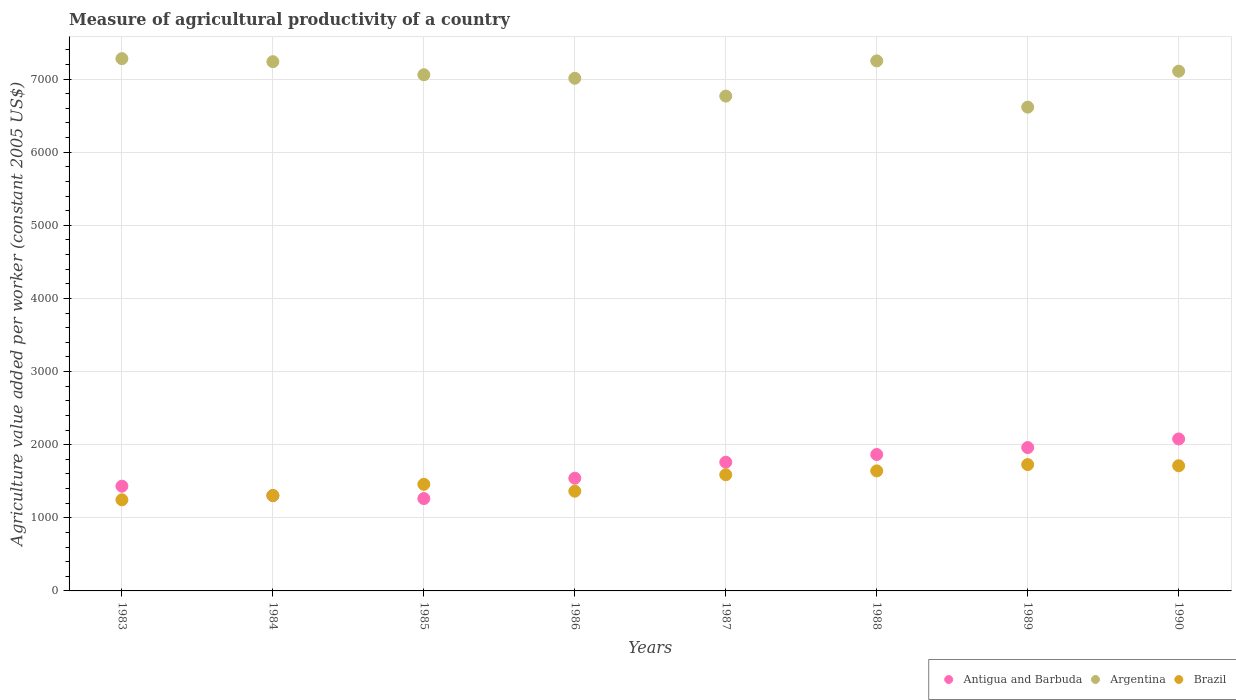What is the measure of agricultural productivity in Brazil in 1988?
Your answer should be very brief. 1641.28. Across all years, what is the maximum measure of agricultural productivity in Antigua and Barbuda?
Your answer should be compact. 2078.08. Across all years, what is the minimum measure of agricultural productivity in Brazil?
Provide a succinct answer. 1246. In which year was the measure of agricultural productivity in Brazil maximum?
Make the answer very short. 1989. What is the total measure of agricultural productivity in Argentina in the graph?
Your answer should be compact. 5.63e+04. What is the difference between the measure of agricultural productivity in Antigua and Barbuda in 1983 and that in 1984?
Offer a terse response. 130.05. What is the difference between the measure of agricultural productivity in Argentina in 1986 and the measure of agricultural productivity in Antigua and Barbuda in 1990?
Your answer should be compact. 4932.41. What is the average measure of agricultural productivity in Brazil per year?
Your answer should be compact. 1505.25. In the year 1989, what is the difference between the measure of agricultural productivity in Antigua and Barbuda and measure of agricultural productivity in Argentina?
Offer a terse response. -4655.16. What is the ratio of the measure of agricultural productivity in Argentina in 1987 to that in 1990?
Make the answer very short. 0.95. Is the measure of agricultural productivity in Antigua and Barbuda in 1985 less than that in 1987?
Your answer should be very brief. Yes. What is the difference between the highest and the second highest measure of agricultural productivity in Antigua and Barbuda?
Your response must be concise. 117.46. What is the difference between the highest and the lowest measure of agricultural productivity in Antigua and Barbuda?
Offer a terse response. 815.05. In how many years, is the measure of agricultural productivity in Argentina greater than the average measure of agricultural productivity in Argentina taken over all years?
Your answer should be very brief. 5. Does the measure of agricultural productivity in Antigua and Barbuda monotonically increase over the years?
Your answer should be compact. No. How many dotlines are there?
Your answer should be compact. 3. What is the difference between two consecutive major ticks on the Y-axis?
Keep it short and to the point. 1000. Are the values on the major ticks of Y-axis written in scientific E-notation?
Keep it short and to the point. No. Does the graph contain any zero values?
Keep it short and to the point. No. Where does the legend appear in the graph?
Your response must be concise. Bottom right. How many legend labels are there?
Your answer should be compact. 3. How are the legend labels stacked?
Keep it short and to the point. Horizontal. What is the title of the graph?
Make the answer very short. Measure of agricultural productivity of a country. What is the label or title of the Y-axis?
Your answer should be very brief. Agriculture value added per worker (constant 2005 US$). What is the Agriculture value added per worker (constant 2005 US$) of Antigua and Barbuda in 1983?
Offer a very short reply. 1432.54. What is the Agriculture value added per worker (constant 2005 US$) in Argentina in 1983?
Make the answer very short. 7278.97. What is the Agriculture value added per worker (constant 2005 US$) in Brazil in 1983?
Provide a short and direct response. 1246. What is the Agriculture value added per worker (constant 2005 US$) in Antigua and Barbuda in 1984?
Make the answer very short. 1302.49. What is the Agriculture value added per worker (constant 2005 US$) in Argentina in 1984?
Give a very brief answer. 7237.52. What is the Agriculture value added per worker (constant 2005 US$) of Brazil in 1984?
Your answer should be compact. 1304.93. What is the Agriculture value added per worker (constant 2005 US$) of Antigua and Barbuda in 1985?
Give a very brief answer. 1263.03. What is the Agriculture value added per worker (constant 2005 US$) of Argentina in 1985?
Provide a succinct answer. 7058.64. What is the Agriculture value added per worker (constant 2005 US$) of Brazil in 1985?
Your answer should be compact. 1457.79. What is the Agriculture value added per worker (constant 2005 US$) in Antigua and Barbuda in 1986?
Offer a terse response. 1541.44. What is the Agriculture value added per worker (constant 2005 US$) in Argentina in 1986?
Ensure brevity in your answer.  7010.49. What is the Agriculture value added per worker (constant 2005 US$) of Brazil in 1986?
Give a very brief answer. 1363.88. What is the Agriculture value added per worker (constant 2005 US$) in Antigua and Barbuda in 1987?
Keep it short and to the point. 1760.21. What is the Agriculture value added per worker (constant 2005 US$) in Argentina in 1987?
Ensure brevity in your answer.  6766.74. What is the Agriculture value added per worker (constant 2005 US$) in Brazil in 1987?
Your answer should be very brief. 1588.76. What is the Agriculture value added per worker (constant 2005 US$) of Antigua and Barbuda in 1988?
Your answer should be compact. 1865.43. What is the Agriculture value added per worker (constant 2005 US$) of Argentina in 1988?
Provide a short and direct response. 7248.35. What is the Agriculture value added per worker (constant 2005 US$) in Brazil in 1988?
Your response must be concise. 1641.28. What is the Agriculture value added per worker (constant 2005 US$) of Antigua and Barbuda in 1989?
Your answer should be compact. 1960.62. What is the Agriculture value added per worker (constant 2005 US$) in Argentina in 1989?
Ensure brevity in your answer.  6615.78. What is the Agriculture value added per worker (constant 2005 US$) of Brazil in 1989?
Offer a very short reply. 1727.74. What is the Agriculture value added per worker (constant 2005 US$) in Antigua and Barbuda in 1990?
Your answer should be very brief. 2078.08. What is the Agriculture value added per worker (constant 2005 US$) in Argentina in 1990?
Provide a succinct answer. 7107.59. What is the Agriculture value added per worker (constant 2005 US$) of Brazil in 1990?
Provide a succinct answer. 1711.61. Across all years, what is the maximum Agriculture value added per worker (constant 2005 US$) of Antigua and Barbuda?
Give a very brief answer. 2078.08. Across all years, what is the maximum Agriculture value added per worker (constant 2005 US$) in Argentina?
Your answer should be compact. 7278.97. Across all years, what is the maximum Agriculture value added per worker (constant 2005 US$) in Brazil?
Offer a very short reply. 1727.74. Across all years, what is the minimum Agriculture value added per worker (constant 2005 US$) of Antigua and Barbuda?
Offer a terse response. 1263.03. Across all years, what is the minimum Agriculture value added per worker (constant 2005 US$) in Argentina?
Give a very brief answer. 6615.78. Across all years, what is the minimum Agriculture value added per worker (constant 2005 US$) of Brazil?
Keep it short and to the point. 1246. What is the total Agriculture value added per worker (constant 2005 US$) in Antigua and Barbuda in the graph?
Ensure brevity in your answer.  1.32e+04. What is the total Agriculture value added per worker (constant 2005 US$) in Argentina in the graph?
Your response must be concise. 5.63e+04. What is the total Agriculture value added per worker (constant 2005 US$) in Brazil in the graph?
Give a very brief answer. 1.20e+04. What is the difference between the Agriculture value added per worker (constant 2005 US$) of Antigua and Barbuda in 1983 and that in 1984?
Ensure brevity in your answer.  130.05. What is the difference between the Agriculture value added per worker (constant 2005 US$) in Argentina in 1983 and that in 1984?
Your answer should be compact. 41.45. What is the difference between the Agriculture value added per worker (constant 2005 US$) in Brazil in 1983 and that in 1984?
Keep it short and to the point. -58.94. What is the difference between the Agriculture value added per worker (constant 2005 US$) of Antigua and Barbuda in 1983 and that in 1985?
Your answer should be very brief. 169.51. What is the difference between the Agriculture value added per worker (constant 2005 US$) in Argentina in 1983 and that in 1985?
Offer a very short reply. 220.33. What is the difference between the Agriculture value added per worker (constant 2005 US$) of Brazil in 1983 and that in 1985?
Keep it short and to the point. -211.8. What is the difference between the Agriculture value added per worker (constant 2005 US$) in Antigua and Barbuda in 1983 and that in 1986?
Give a very brief answer. -108.9. What is the difference between the Agriculture value added per worker (constant 2005 US$) in Argentina in 1983 and that in 1986?
Ensure brevity in your answer.  268.49. What is the difference between the Agriculture value added per worker (constant 2005 US$) of Brazil in 1983 and that in 1986?
Your answer should be compact. -117.89. What is the difference between the Agriculture value added per worker (constant 2005 US$) in Antigua and Barbuda in 1983 and that in 1987?
Provide a succinct answer. -327.67. What is the difference between the Agriculture value added per worker (constant 2005 US$) of Argentina in 1983 and that in 1987?
Keep it short and to the point. 512.23. What is the difference between the Agriculture value added per worker (constant 2005 US$) of Brazil in 1983 and that in 1987?
Your answer should be very brief. -342.76. What is the difference between the Agriculture value added per worker (constant 2005 US$) of Antigua and Barbuda in 1983 and that in 1988?
Ensure brevity in your answer.  -432.89. What is the difference between the Agriculture value added per worker (constant 2005 US$) of Argentina in 1983 and that in 1988?
Make the answer very short. 30.62. What is the difference between the Agriculture value added per worker (constant 2005 US$) of Brazil in 1983 and that in 1988?
Provide a succinct answer. -395.29. What is the difference between the Agriculture value added per worker (constant 2005 US$) in Antigua and Barbuda in 1983 and that in 1989?
Keep it short and to the point. -528.08. What is the difference between the Agriculture value added per worker (constant 2005 US$) of Argentina in 1983 and that in 1989?
Provide a succinct answer. 663.19. What is the difference between the Agriculture value added per worker (constant 2005 US$) in Brazil in 1983 and that in 1989?
Provide a succinct answer. -481.74. What is the difference between the Agriculture value added per worker (constant 2005 US$) of Antigua and Barbuda in 1983 and that in 1990?
Provide a short and direct response. -645.54. What is the difference between the Agriculture value added per worker (constant 2005 US$) of Argentina in 1983 and that in 1990?
Offer a terse response. 171.38. What is the difference between the Agriculture value added per worker (constant 2005 US$) in Brazil in 1983 and that in 1990?
Offer a terse response. -465.61. What is the difference between the Agriculture value added per worker (constant 2005 US$) in Antigua and Barbuda in 1984 and that in 1985?
Provide a succinct answer. 39.46. What is the difference between the Agriculture value added per worker (constant 2005 US$) in Argentina in 1984 and that in 1985?
Provide a succinct answer. 178.88. What is the difference between the Agriculture value added per worker (constant 2005 US$) in Brazil in 1984 and that in 1985?
Provide a short and direct response. -152.86. What is the difference between the Agriculture value added per worker (constant 2005 US$) of Antigua and Barbuda in 1984 and that in 1986?
Your answer should be very brief. -238.95. What is the difference between the Agriculture value added per worker (constant 2005 US$) of Argentina in 1984 and that in 1986?
Keep it short and to the point. 227.03. What is the difference between the Agriculture value added per worker (constant 2005 US$) in Brazil in 1984 and that in 1986?
Your answer should be very brief. -58.95. What is the difference between the Agriculture value added per worker (constant 2005 US$) of Antigua and Barbuda in 1984 and that in 1987?
Ensure brevity in your answer.  -457.73. What is the difference between the Agriculture value added per worker (constant 2005 US$) in Argentina in 1984 and that in 1987?
Your response must be concise. 470.78. What is the difference between the Agriculture value added per worker (constant 2005 US$) in Brazil in 1984 and that in 1987?
Your answer should be compact. -283.82. What is the difference between the Agriculture value added per worker (constant 2005 US$) of Antigua and Barbuda in 1984 and that in 1988?
Offer a very short reply. -562.94. What is the difference between the Agriculture value added per worker (constant 2005 US$) in Argentina in 1984 and that in 1988?
Your response must be concise. -10.83. What is the difference between the Agriculture value added per worker (constant 2005 US$) in Brazil in 1984 and that in 1988?
Make the answer very short. -336.35. What is the difference between the Agriculture value added per worker (constant 2005 US$) in Antigua and Barbuda in 1984 and that in 1989?
Your answer should be compact. -658.13. What is the difference between the Agriculture value added per worker (constant 2005 US$) in Argentina in 1984 and that in 1989?
Your answer should be very brief. 621.74. What is the difference between the Agriculture value added per worker (constant 2005 US$) of Brazil in 1984 and that in 1989?
Offer a terse response. -422.81. What is the difference between the Agriculture value added per worker (constant 2005 US$) of Antigua and Barbuda in 1984 and that in 1990?
Your response must be concise. -775.59. What is the difference between the Agriculture value added per worker (constant 2005 US$) in Argentina in 1984 and that in 1990?
Provide a short and direct response. 129.93. What is the difference between the Agriculture value added per worker (constant 2005 US$) in Brazil in 1984 and that in 1990?
Provide a succinct answer. -406.68. What is the difference between the Agriculture value added per worker (constant 2005 US$) in Antigua and Barbuda in 1985 and that in 1986?
Ensure brevity in your answer.  -278.41. What is the difference between the Agriculture value added per worker (constant 2005 US$) in Argentina in 1985 and that in 1986?
Provide a succinct answer. 48.16. What is the difference between the Agriculture value added per worker (constant 2005 US$) of Brazil in 1985 and that in 1986?
Provide a succinct answer. 93.91. What is the difference between the Agriculture value added per worker (constant 2005 US$) of Antigua and Barbuda in 1985 and that in 1987?
Ensure brevity in your answer.  -497.18. What is the difference between the Agriculture value added per worker (constant 2005 US$) of Argentina in 1985 and that in 1987?
Ensure brevity in your answer.  291.9. What is the difference between the Agriculture value added per worker (constant 2005 US$) of Brazil in 1985 and that in 1987?
Your answer should be compact. -130.96. What is the difference between the Agriculture value added per worker (constant 2005 US$) in Antigua and Barbuda in 1985 and that in 1988?
Your answer should be very brief. -602.4. What is the difference between the Agriculture value added per worker (constant 2005 US$) in Argentina in 1985 and that in 1988?
Keep it short and to the point. -189.71. What is the difference between the Agriculture value added per worker (constant 2005 US$) of Brazil in 1985 and that in 1988?
Provide a succinct answer. -183.49. What is the difference between the Agriculture value added per worker (constant 2005 US$) in Antigua and Barbuda in 1985 and that in 1989?
Ensure brevity in your answer.  -697.59. What is the difference between the Agriculture value added per worker (constant 2005 US$) in Argentina in 1985 and that in 1989?
Keep it short and to the point. 442.86. What is the difference between the Agriculture value added per worker (constant 2005 US$) in Brazil in 1985 and that in 1989?
Your answer should be very brief. -269.95. What is the difference between the Agriculture value added per worker (constant 2005 US$) of Antigua and Barbuda in 1985 and that in 1990?
Your answer should be compact. -815.05. What is the difference between the Agriculture value added per worker (constant 2005 US$) in Argentina in 1985 and that in 1990?
Provide a succinct answer. -48.95. What is the difference between the Agriculture value added per worker (constant 2005 US$) in Brazil in 1985 and that in 1990?
Your answer should be very brief. -253.81. What is the difference between the Agriculture value added per worker (constant 2005 US$) of Antigua and Barbuda in 1986 and that in 1987?
Make the answer very short. -218.77. What is the difference between the Agriculture value added per worker (constant 2005 US$) of Argentina in 1986 and that in 1987?
Ensure brevity in your answer.  243.75. What is the difference between the Agriculture value added per worker (constant 2005 US$) of Brazil in 1986 and that in 1987?
Your answer should be very brief. -224.87. What is the difference between the Agriculture value added per worker (constant 2005 US$) in Antigua and Barbuda in 1986 and that in 1988?
Ensure brevity in your answer.  -323.99. What is the difference between the Agriculture value added per worker (constant 2005 US$) of Argentina in 1986 and that in 1988?
Make the answer very short. -237.87. What is the difference between the Agriculture value added per worker (constant 2005 US$) of Brazil in 1986 and that in 1988?
Ensure brevity in your answer.  -277.4. What is the difference between the Agriculture value added per worker (constant 2005 US$) of Antigua and Barbuda in 1986 and that in 1989?
Offer a terse response. -419.18. What is the difference between the Agriculture value added per worker (constant 2005 US$) of Argentina in 1986 and that in 1989?
Provide a succinct answer. 394.7. What is the difference between the Agriculture value added per worker (constant 2005 US$) of Brazil in 1986 and that in 1989?
Offer a very short reply. -363.85. What is the difference between the Agriculture value added per worker (constant 2005 US$) of Antigua and Barbuda in 1986 and that in 1990?
Ensure brevity in your answer.  -536.64. What is the difference between the Agriculture value added per worker (constant 2005 US$) in Argentina in 1986 and that in 1990?
Offer a terse response. -97.11. What is the difference between the Agriculture value added per worker (constant 2005 US$) of Brazil in 1986 and that in 1990?
Keep it short and to the point. -347.72. What is the difference between the Agriculture value added per worker (constant 2005 US$) of Antigua and Barbuda in 1987 and that in 1988?
Offer a very short reply. -105.22. What is the difference between the Agriculture value added per worker (constant 2005 US$) of Argentina in 1987 and that in 1988?
Your answer should be compact. -481.61. What is the difference between the Agriculture value added per worker (constant 2005 US$) in Brazil in 1987 and that in 1988?
Your response must be concise. -52.53. What is the difference between the Agriculture value added per worker (constant 2005 US$) in Antigua and Barbuda in 1987 and that in 1989?
Make the answer very short. -200.41. What is the difference between the Agriculture value added per worker (constant 2005 US$) in Argentina in 1987 and that in 1989?
Offer a very short reply. 150.95. What is the difference between the Agriculture value added per worker (constant 2005 US$) in Brazil in 1987 and that in 1989?
Provide a succinct answer. -138.98. What is the difference between the Agriculture value added per worker (constant 2005 US$) in Antigua and Barbuda in 1987 and that in 1990?
Keep it short and to the point. -317.86. What is the difference between the Agriculture value added per worker (constant 2005 US$) of Argentina in 1987 and that in 1990?
Your answer should be very brief. -340.85. What is the difference between the Agriculture value added per worker (constant 2005 US$) in Brazil in 1987 and that in 1990?
Provide a succinct answer. -122.85. What is the difference between the Agriculture value added per worker (constant 2005 US$) in Antigua and Barbuda in 1988 and that in 1989?
Ensure brevity in your answer.  -95.19. What is the difference between the Agriculture value added per worker (constant 2005 US$) of Argentina in 1988 and that in 1989?
Offer a very short reply. 632.57. What is the difference between the Agriculture value added per worker (constant 2005 US$) of Brazil in 1988 and that in 1989?
Ensure brevity in your answer.  -86.46. What is the difference between the Agriculture value added per worker (constant 2005 US$) in Antigua and Barbuda in 1988 and that in 1990?
Ensure brevity in your answer.  -212.65. What is the difference between the Agriculture value added per worker (constant 2005 US$) in Argentina in 1988 and that in 1990?
Provide a short and direct response. 140.76. What is the difference between the Agriculture value added per worker (constant 2005 US$) of Brazil in 1988 and that in 1990?
Give a very brief answer. -70.33. What is the difference between the Agriculture value added per worker (constant 2005 US$) of Antigua and Barbuda in 1989 and that in 1990?
Provide a succinct answer. -117.46. What is the difference between the Agriculture value added per worker (constant 2005 US$) of Argentina in 1989 and that in 1990?
Give a very brief answer. -491.81. What is the difference between the Agriculture value added per worker (constant 2005 US$) of Brazil in 1989 and that in 1990?
Offer a terse response. 16.13. What is the difference between the Agriculture value added per worker (constant 2005 US$) in Antigua and Barbuda in 1983 and the Agriculture value added per worker (constant 2005 US$) in Argentina in 1984?
Make the answer very short. -5804.98. What is the difference between the Agriculture value added per worker (constant 2005 US$) in Antigua and Barbuda in 1983 and the Agriculture value added per worker (constant 2005 US$) in Brazil in 1984?
Your answer should be compact. 127.61. What is the difference between the Agriculture value added per worker (constant 2005 US$) in Argentina in 1983 and the Agriculture value added per worker (constant 2005 US$) in Brazil in 1984?
Your response must be concise. 5974.04. What is the difference between the Agriculture value added per worker (constant 2005 US$) of Antigua and Barbuda in 1983 and the Agriculture value added per worker (constant 2005 US$) of Argentina in 1985?
Your answer should be very brief. -5626.1. What is the difference between the Agriculture value added per worker (constant 2005 US$) in Antigua and Barbuda in 1983 and the Agriculture value added per worker (constant 2005 US$) in Brazil in 1985?
Make the answer very short. -25.26. What is the difference between the Agriculture value added per worker (constant 2005 US$) in Argentina in 1983 and the Agriculture value added per worker (constant 2005 US$) in Brazil in 1985?
Offer a very short reply. 5821.18. What is the difference between the Agriculture value added per worker (constant 2005 US$) in Antigua and Barbuda in 1983 and the Agriculture value added per worker (constant 2005 US$) in Argentina in 1986?
Ensure brevity in your answer.  -5577.95. What is the difference between the Agriculture value added per worker (constant 2005 US$) in Antigua and Barbuda in 1983 and the Agriculture value added per worker (constant 2005 US$) in Brazil in 1986?
Give a very brief answer. 68.65. What is the difference between the Agriculture value added per worker (constant 2005 US$) in Argentina in 1983 and the Agriculture value added per worker (constant 2005 US$) in Brazil in 1986?
Provide a short and direct response. 5915.09. What is the difference between the Agriculture value added per worker (constant 2005 US$) in Antigua and Barbuda in 1983 and the Agriculture value added per worker (constant 2005 US$) in Argentina in 1987?
Give a very brief answer. -5334.2. What is the difference between the Agriculture value added per worker (constant 2005 US$) in Antigua and Barbuda in 1983 and the Agriculture value added per worker (constant 2005 US$) in Brazil in 1987?
Keep it short and to the point. -156.22. What is the difference between the Agriculture value added per worker (constant 2005 US$) in Argentina in 1983 and the Agriculture value added per worker (constant 2005 US$) in Brazil in 1987?
Ensure brevity in your answer.  5690.22. What is the difference between the Agriculture value added per worker (constant 2005 US$) in Antigua and Barbuda in 1983 and the Agriculture value added per worker (constant 2005 US$) in Argentina in 1988?
Make the answer very short. -5815.81. What is the difference between the Agriculture value added per worker (constant 2005 US$) of Antigua and Barbuda in 1983 and the Agriculture value added per worker (constant 2005 US$) of Brazil in 1988?
Offer a terse response. -208.74. What is the difference between the Agriculture value added per worker (constant 2005 US$) of Argentina in 1983 and the Agriculture value added per worker (constant 2005 US$) of Brazil in 1988?
Ensure brevity in your answer.  5637.69. What is the difference between the Agriculture value added per worker (constant 2005 US$) in Antigua and Barbuda in 1983 and the Agriculture value added per worker (constant 2005 US$) in Argentina in 1989?
Ensure brevity in your answer.  -5183.25. What is the difference between the Agriculture value added per worker (constant 2005 US$) of Antigua and Barbuda in 1983 and the Agriculture value added per worker (constant 2005 US$) of Brazil in 1989?
Provide a short and direct response. -295.2. What is the difference between the Agriculture value added per worker (constant 2005 US$) in Argentina in 1983 and the Agriculture value added per worker (constant 2005 US$) in Brazil in 1989?
Ensure brevity in your answer.  5551.23. What is the difference between the Agriculture value added per worker (constant 2005 US$) of Antigua and Barbuda in 1983 and the Agriculture value added per worker (constant 2005 US$) of Argentina in 1990?
Your response must be concise. -5675.05. What is the difference between the Agriculture value added per worker (constant 2005 US$) in Antigua and Barbuda in 1983 and the Agriculture value added per worker (constant 2005 US$) in Brazil in 1990?
Give a very brief answer. -279.07. What is the difference between the Agriculture value added per worker (constant 2005 US$) in Argentina in 1983 and the Agriculture value added per worker (constant 2005 US$) in Brazil in 1990?
Make the answer very short. 5567.37. What is the difference between the Agriculture value added per worker (constant 2005 US$) of Antigua and Barbuda in 1984 and the Agriculture value added per worker (constant 2005 US$) of Argentina in 1985?
Offer a very short reply. -5756.16. What is the difference between the Agriculture value added per worker (constant 2005 US$) of Antigua and Barbuda in 1984 and the Agriculture value added per worker (constant 2005 US$) of Brazil in 1985?
Ensure brevity in your answer.  -155.31. What is the difference between the Agriculture value added per worker (constant 2005 US$) in Argentina in 1984 and the Agriculture value added per worker (constant 2005 US$) in Brazil in 1985?
Give a very brief answer. 5779.73. What is the difference between the Agriculture value added per worker (constant 2005 US$) in Antigua and Barbuda in 1984 and the Agriculture value added per worker (constant 2005 US$) in Argentina in 1986?
Offer a terse response. -5708. What is the difference between the Agriculture value added per worker (constant 2005 US$) in Antigua and Barbuda in 1984 and the Agriculture value added per worker (constant 2005 US$) in Brazil in 1986?
Give a very brief answer. -61.4. What is the difference between the Agriculture value added per worker (constant 2005 US$) of Argentina in 1984 and the Agriculture value added per worker (constant 2005 US$) of Brazil in 1986?
Provide a short and direct response. 5873.64. What is the difference between the Agriculture value added per worker (constant 2005 US$) in Antigua and Barbuda in 1984 and the Agriculture value added per worker (constant 2005 US$) in Argentina in 1987?
Make the answer very short. -5464.25. What is the difference between the Agriculture value added per worker (constant 2005 US$) in Antigua and Barbuda in 1984 and the Agriculture value added per worker (constant 2005 US$) in Brazil in 1987?
Your answer should be very brief. -286.27. What is the difference between the Agriculture value added per worker (constant 2005 US$) in Argentina in 1984 and the Agriculture value added per worker (constant 2005 US$) in Brazil in 1987?
Your answer should be very brief. 5648.76. What is the difference between the Agriculture value added per worker (constant 2005 US$) in Antigua and Barbuda in 1984 and the Agriculture value added per worker (constant 2005 US$) in Argentina in 1988?
Offer a terse response. -5945.87. What is the difference between the Agriculture value added per worker (constant 2005 US$) in Antigua and Barbuda in 1984 and the Agriculture value added per worker (constant 2005 US$) in Brazil in 1988?
Ensure brevity in your answer.  -338.8. What is the difference between the Agriculture value added per worker (constant 2005 US$) in Argentina in 1984 and the Agriculture value added per worker (constant 2005 US$) in Brazil in 1988?
Provide a short and direct response. 5596.24. What is the difference between the Agriculture value added per worker (constant 2005 US$) of Antigua and Barbuda in 1984 and the Agriculture value added per worker (constant 2005 US$) of Argentina in 1989?
Provide a succinct answer. -5313.3. What is the difference between the Agriculture value added per worker (constant 2005 US$) in Antigua and Barbuda in 1984 and the Agriculture value added per worker (constant 2005 US$) in Brazil in 1989?
Your answer should be compact. -425.25. What is the difference between the Agriculture value added per worker (constant 2005 US$) in Argentina in 1984 and the Agriculture value added per worker (constant 2005 US$) in Brazil in 1989?
Your answer should be very brief. 5509.78. What is the difference between the Agriculture value added per worker (constant 2005 US$) of Antigua and Barbuda in 1984 and the Agriculture value added per worker (constant 2005 US$) of Argentina in 1990?
Offer a terse response. -5805.11. What is the difference between the Agriculture value added per worker (constant 2005 US$) in Antigua and Barbuda in 1984 and the Agriculture value added per worker (constant 2005 US$) in Brazil in 1990?
Offer a terse response. -409.12. What is the difference between the Agriculture value added per worker (constant 2005 US$) of Argentina in 1984 and the Agriculture value added per worker (constant 2005 US$) of Brazil in 1990?
Provide a succinct answer. 5525.91. What is the difference between the Agriculture value added per worker (constant 2005 US$) of Antigua and Barbuda in 1985 and the Agriculture value added per worker (constant 2005 US$) of Argentina in 1986?
Provide a short and direct response. -5747.45. What is the difference between the Agriculture value added per worker (constant 2005 US$) in Antigua and Barbuda in 1985 and the Agriculture value added per worker (constant 2005 US$) in Brazil in 1986?
Your response must be concise. -100.85. What is the difference between the Agriculture value added per worker (constant 2005 US$) in Argentina in 1985 and the Agriculture value added per worker (constant 2005 US$) in Brazil in 1986?
Your answer should be compact. 5694.76. What is the difference between the Agriculture value added per worker (constant 2005 US$) in Antigua and Barbuda in 1985 and the Agriculture value added per worker (constant 2005 US$) in Argentina in 1987?
Offer a terse response. -5503.71. What is the difference between the Agriculture value added per worker (constant 2005 US$) of Antigua and Barbuda in 1985 and the Agriculture value added per worker (constant 2005 US$) of Brazil in 1987?
Your answer should be very brief. -325.73. What is the difference between the Agriculture value added per worker (constant 2005 US$) in Argentina in 1985 and the Agriculture value added per worker (constant 2005 US$) in Brazil in 1987?
Offer a very short reply. 5469.89. What is the difference between the Agriculture value added per worker (constant 2005 US$) in Antigua and Barbuda in 1985 and the Agriculture value added per worker (constant 2005 US$) in Argentina in 1988?
Ensure brevity in your answer.  -5985.32. What is the difference between the Agriculture value added per worker (constant 2005 US$) of Antigua and Barbuda in 1985 and the Agriculture value added per worker (constant 2005 US$) of Brazil in 1988?
Your answer should be very brief. -378.25. What is the difference between the Agriculture value added per worker (constant 2005 US$) of Argentina in 1985 and the Agriculture value added per worker (constant 2005 US$) of Brazil in 1988?
Your answer should be compact. 5417.36. What is the difference between the Agriculture value added per worker (constant 2005 US$) in Antigua and Barbuda in 1985 and the Agriculture value added per worker (constant 2005 US$) in Argentina in 1989?
Offer a very short reply. -5352.75. What is the difference between the Agriculture value added per worker (constant 2005 US$) of Antigua and Barbuda in 1985 and the Agriculture value added per worker (constant 2005 US$) of Brazil in 1989?
Offer a terse response. -464.71. What is the difference between the Agriculture value added per worker (constant 2005 US$) in Argentina in 1985 and the Agriculture value added per worker (constant 2005 US$) in Brazil in 1989?
Provide a short and direct response. 5330.9. What is the difference between the Agriculture value added per worker (constant 2005 US$) of Antigua and Barbuda in 1985 and the Agriculture value added per worker (constant 2005 US$) of Argentina in 1990?
Ensure brevity in your answer.  -5844.56. What is the difference between the Agriculture value added per worker (constant 2005 US$) of Antigua and Barbuda in 1985 and the Agriculture value added per worker (constant 2005 US$) of Brazil in 1990?
Give a very brief answer. -448.58. What is the difference between the Agriculture value added per worker (constant 2005 US$) in Argentina in 1985 and the Agriculture value added per worker (constant 2005 US$) in Brazil in 1990?
Ensure brevity in your answer.  5347.04. What is the difference between the Agriculture value added per worker (constant 2005 US$) of Antigua and Barbuda in 1986 and the Agriculture value added per worker (constant 2005 US$) of Argentina in 1987?
Offer a very short reply. -5225.3. What is the difference between the Agriculture value added per worker (constant 2005 US$) of Antigua and Barbuda in 1986 and the Agriculture value added per worker (constant 2005 US$) of Brazil in 1987?
Provide a short and direct response. -47.32. What is the difference between the Agriculture value added per worker (constant 2005 US$) of Argentina in 1986 and the Agriculture value added per worker (constant 2005 US$) of Brazil in 1987?
Offer a very short reply. 5421.73. What is the difference between the Agriculture value added per worker (constant 2005 US$) of Antigua and Barbuda in 1986 and the Agriculture value added per worker (constant 2005 US$) of Argentina in 1988?
Ensure brevity in your answer.  -5706.91. What is the difference between the Agriculture value added per worker (constant 2005 US$) in Antigua and Barbuda in 1986 and the Agriculture value added per worker (constant 2005 US$) in Brazil in 1988?
Your answer should be compact. -99.84. What is the difference between the Agriculture value added per worker (constant 2005 US$) in Argentina in 1986 and the Agriculture value added per worker (constant 2005 US$) in Brazil in 1988?
Your answer should be compact. 5369.2. What is the difference between the Agriculture value added per worker (constant 2005 US$) in Antigua and Barbuda in 1986 and the Agriculture value added per worker (constant 2005 US$) in Argentina in 1989?
Your answer should be very brief. -5074.35. What is the difference between the Agriculture value added per worker (constant 2005 US$) of Antigua and Barbuda in 1986 and the Agriculture value added per worker (constant 2005 US$) of Brazil in 1989?
Offer a very short reply. -186.3. What is the difference between the Agriculture value added per worker (constant 2005 US$) in Argentina in 1986 and the Agriculture value added per worker (constant 2005 US$) in Brazil in 1989?
Keep it short and to the point. 5282.75. What is the difference between the Agriculture value added per worker (constant 2005 US$) in Antigua and Barbuda in 1986 and the Agriculture value added per worker (constant 2005 US$) in Argentina in 1990?
Offer a very short reply. -5566.15. What is the difference between the Agriculture value added per worker (constant 2005 US$) of Antigua and Barbuda in 1986 and the Agriculture value added per worker (constant 2005 US$) of Brazil in 1990?
Make the answer very short. -170.17. What is the difference between the Agriculture value added per worker (constant 2005 US$) in Argentina in 1986 and the Agriculture value added per worker (constant 2005 US$) in Brazil in 1990?
Keep it short and to the point. 5298.88. What is the difference between the Agriculture value added per worker (constant 2005 US$) in Antigua and Barbuda in 1987 and the Agriculture value added per worker (constant 2005 US$) in Argentina in 1988?
Provide a succinct answer. -5488.14. What is the difference between the Agriculture value added per worker (constant 2005 US$) in Antigua and Barbuda in 1987 and the Agriculture value added per worker (constant 2005 US$) in Brazil in 1988?
Provide a succinct answer. 118.93. What is the difference between the Agriculture value added per worker (constant 2005 US$) in Argentina in 1987 and the Agriculture value added per worker (constant 2005 US$) in Brazil in 1988?
Provide a succinct answer. 5125.46. What is the difference between the Agriculture value added per worker (constant 2005 US$) of Antigua and Barbuda in 1987 and the Agriculture value added per worker (constant 2005 US$) of Argentina in 1989?
Ensure brevity in your answer.  -4855.57. What is the difference between the Agriculture value added per worker (constant 2005 US$) in Antigua and Barbuda in 1987 and the Agriculture value added per worker (constant 2005 US$) in Brazil in 1989?
Provide a succinct answer. 32.47. What is the difference between the Agriculture value added per worker (constant 2005 US$) of Argentina in 1987 and the Agriculture value added per worker (constant 2005 US$) of Brazil in 1989?
Offer a very short reply. 5039. What is the difference between the Agriculture value added per worker (constant 2005 US$) of Antigua and Barbuda in 1987 and the Agriculture value added per worker (constant 2005 US$) of Argentina in 1990?
Provide a succinct answer. -5347.38. What is the difference between the Agriculture value added per worker (constant 2005 US$) in Antigua and Barbuda in 1987 and the Agriculture value added per worker (constant 2005 US$) in Brazil in 1990?
Provide a succinct answer. 48.61. What is the difference between the Agriculture value added per worker (constant 2005 US$) in Argentina in 1987 and the Agriculture value added per worker (constant 2005 US$) in Brazil in 1990?
Offer a very short reply. 5055.13. What is the difference between the Agriculture value added per worker (constant 2005 US$) of Antigua and Barbuda in 1988 and the Agriculture value added per worker (constant 2005 US$) of Argentina in 1989?
Your response must be concise. -4750.36. What is the difference between the Agriculture value added per worker (constant 2005 US$) in Antigua and Barbuda in 1988 and the Agriculture value added per worker (constant 2005 US$) in Brazil in 1989?
Your response must be concise. 137.69. What is the difference between the Agriculture value added per worker (constant 2005 US$) of Argentina in 1988 and the Agriculture value added per worker (constant 2005 US$) of Brazil in 1989?
Offer a very short reply. 5520.61. What is the difference between the Agriculture value added per worker (constant 2005 US$) in Antigua and Barbuda in 1988 and the Agriculture value added per worker (constant 2005 US$) in Argentina in 1990?
Your answer should be very brief. -5242.17. What is the difference between the Agriculture value added per worker (constant 2005 US$) in Antigua and Barbuda in 1988 and the Agriculture value added per worker (constant 2005 US$) in Brazil in 1990?
Make the answer very short. 153.82. What is the difference between the Agriculture value added per worker (constant 2005 US$) of Argentina in 1988 and the Agriculture value added per worker (constant 2005 US$) of Brazil in 1990?
Ensure brevity in your answer.  5536.75. What is the difference between the Agriculture value added per worker (constant 2005 US$) in Antigua and Barbuda in 1989 and the Agriculture value added per worker (constant 2005 US$) in Argentina in 1990?
Your response must be concise. -5146.97. What is the difference between the Agriculture value added per worker (constant 2005 US$) of Antigua and Barbuda in 1989 and the Agriculture value added per worker (constant 2005 US$) of Brazil in 1990?
Your response must be concise. 249.01. What is the difference between the Agriculture value added per worker (constant 2005 US$) in Argentina in 1989 and the Agriculture value added per worker (constant 2005 US$) in Brazil in 1990?
Offer a terse response. 4904.18. What is the average Agriculture value added per worker (constant 2005 US$) of Antigua and Barbuda per year?
Keep it short and to the point. 1650.48. What is the average Agriculture value added per worker (constant 2005 US$) in Argentina per year?
Give a very brief answer. 7040.51. What is the average Agriculture value added per worker (constant 2005 US$) in Brazil per year?
Your response must be concise. 1505.25. In the year 1983, what is the difference between the Agriculture value added per worker (constant 2005 US$) of Antigua and Barbuda and Agriculture value added per worker (constant 2005 US$) of Argentina?
Ensure brevity in your answer.  -5846.43. In the year 1983, what is the difference between the Agriculture value added per worker (constant 2005 US$) of Antigua and Barbuda and Agriculture value added per worker (constant 2005 US$) of Brazil?
Provide a short and direct response. 186.54. In the year 1983, what is the difference between the Agriculture value added per worker (constant 2005 US$) in Argentina and Agriculture value added per worker (constant 2005 US$) in Brazil?
Provide a succinct answer. 6032.98. In the year 1984, what is the difference between the Agriculture value added per worker (constant 2005 US$) of Antigua and Barbuda and Agriculture value added per worker (constant 2005 US$) of Argentina?
Provide a succinct answer. -5935.03. In the year 1984, what is the difference between the Agriculture value added per worker (constant 2005 US$) in Antigua and Barbuda and Agriculture value added per worker (constant 2005 US$) in Brazil?
Give a very brief answer. -2.45. In the year 1984, what is the difference between the Agriculture value added per worker (constant 2005 US$) of Argentina and Agriculture value added per worker (constant 2005 US$) of Brazil?
Keep it short and to the point. 5932.59. In the year 1985, what is the difference between the Agriculture value added per worker (constant 2005 US$) in Antigua and Barbuda and Agriculture value added per worker (constant 2005 US$) in Argentina?
Your answer should be very brief. -5795.61. In the year 1985, what is the difference between the Agriculture value added per worker (constant 2005 US$) in Antigua and Barbuda and Agriculture value added per worker (constant 2005 US$) in Brazil?
Provide a short and direct response. -194.76. In the year 1985, what is the difference between the Agriculture value added per worker (constant 2005 US$) in Argentina and Agriculture value added per worker (constant 2005 US$) in Brazil?
Your response must be concise. 5600.85. In the year 1986, what is the difference between the Agriculture value added per worker (constant 2005 US$) in Antigua and Barbuda and Agriculture value added per worker (constant 2005 US$) in Argentina?
Your answer should be very brief. -5469.05. In the year 1986, what is the difference between the Agriculture value added per worker (constant 2005 US$) in Antigua and Barbuda and Agriculture value added per worker (constant 2005 US$) in Brazil?
Offer a very short reply. 177.55. In the year 1986, what is the difference between the Agriculture value added per worker (constant 2005 US$) of Argentina and Agriculture value added per worker (constant 2005 US$) of Brazil?
Your answer should be very brief. 5646.6. In the year 1987, what is the difference between the Agriculture value added per worker (constant 2005 US$) of Antigua and Barbuda and Agriculture value added per worker (constant 2005 US$) of Argentina?
Keep it short and to the point. -5006.53. In the year 1987, what is the difference between the Agriculture value added per worker (constant 2005 US$) in Antigua and Barbuda and Agriculture value added per worker (constant 2005 US$) in Brazil?
Give a very brief answer. 171.46. In the year 1987, what is the difference between the Agriculture value added per worker (constant 2005 US$) in Argentina and Agriculture value added per worker (constant 2005 US$) in Brazil?
Keep it short and to the point. 5177.98. In the year 1988, what is the difference between the Agriculture value added per worker (constant 2005 US$) of Antigua and Barbuda and Agriculture value added per worker (constant 2005 US$) of Argentina?
Provide a succinct answer. -5382.92. In the year 1988, what is the difference between the Agriculture value added per worker (constant 2005 US$) in Antigua and Barbuda and Agriculture value added per worker (constant 2005 US$) in Brazil?
Give a very brief answer. 224.15. In the year 1988, what is the difference between the Agriculture value added per worker (constant 2005 US$) of Argentina and Agriculture value added per worker (constant 2005 US$) of Brazil?
Offer a very short reply. 5607.07. In the year 1989, what is the difference between the Agriculture value added per worker (constant 2005 US$) in Antigua and Barbuda and Agriculture value added per worker (constant 2005 US$) in Argentina?
Ensure brevity in your answer.  -4655.16. In the year 1989, what is the difference between the Agriculture value added per worker (constant 2005 US$) in Antigua and Barbuda and Agriculture value added per worker (constant 2005 US$) in Brazil?
Offer a very short reply. 232.88. In the year 1989, what is the difference between the Agriculture value added per worker (constant 2005 US$) of Argentina and Agriculture value added per worker (constant 2005 US$) of Brazil?
Offer a terse response. 4888.04. In the year 1990, what is the difference between the Agriculture value added per worker (constant 2005 US$) of Antigua and Barbuda and Agriculture value added per worker (constant 2005 US$) of Argentina?
Make the answer very short. -5029.52. In the year 1990, what is the difference between the Agriculture value added per worker (constant 2005 US$) in Antigua and Barbuda and Agriculture value added per worker (constant 2005 US$) in Brazil?
Your answer should be very brief. 366.47. In the year 1990, what is the difference between the Agriculture value added per worker (constant 2005 US$) in Argentina and Agriculture value added per worker (constant 2005 US$) in Brazil?
Your response must be concise. 5395.99. What is the ratio of the Agriculture value added per worker (constant 2005 US$) of Antigua and Barbuda in 1983 to that in 1984?
Provide a short and direct response. 1.1. What is the ratio of the Agriculture value added per worker (constant 2005 US$) in Argentina in 1983 to that in 1984?
Keep it short and to the point. 1.01. What is the ratio of the Agriculture value added per worker (constant 2005 US$) in Brazil in 1983 to that in 1984?
Your response must be concise. 0.95. What is the ratio of the Agriculture value added per worker (constant 2005 US$) in Antigua and Barbuda in 1983 to that in 1985?
Make the answer very short. 1.13. What is the ratio of the Agriculture value added per worker (constant 2005 US$) in Argentina in 1983 to that in 1985?
Provide a short and direct response. 1.03. What is the ratio of the Agriculture value added per worker (constant 2005 US$) in Brazil in 1983 to that in 1985?
Keep it short and to the point. 0.85. What is the ratio of the Agriculture value added per worker (constant 2005 US$) in Antigua and Barbuda in 1983 to that in 1986?
Provide a short and direct response. 0.93. What is the ratio of the Agriculture value added per worker (constant 2005 US$) in Argentina in 1983 to that in 1986?
Keep it short and to the point. 1.04. What is the ratio of the Agriculture value added per worker (constant 2005 US$) in Brazil in 1983 to that in 1986?
Your answer should be compact. 0.91. What is the ratio of the Agriculture value added per worker (constant 2005 US$) in Antigua and Barbuda in 1983 to that in 1987?
Provide a succinct answer. 0.81. What is the ratio of the Agriculture value added per worker (constant 2005 US$) in Argentina in 1983 to that in 1987?
Offer a terse response. 1.08. What is the ratio of the Agriculture value added per worker (constant 2005 US$) of Brazil in 1983 to that in 1987?
Your answer should be compact. 0.78. What is the ratio of the Agriculture value added per worker (constant 2005 US$) in Antigua and Barbuda in 1983 to that in 1988?
Your answer should be compact. 0.77. What is the ratio of the Agriculture value added per worker (constant 2005 US$) of Argentina in 1983 to that in 1988?
Your response must be concise. 1. What is the ratio of the Agriculture value added per worker (constant 2005 US$) of Brazil in 1983 to that in 1988?
Offer a terse response. 0.76. What is the ratio of the Agriculture value added per worker (constant 2005 US$) in Antigua and Barbuda in 1983 to that in 1989?
Make the answer very short. 0.73. What is the ratio of the Agriculture value added per worker (constant 2005 US$) of Argentina in 1983 to that in 1989?
Your response must be concise. 1.1. What is the ratio of the Agriculture value added per worker (constant 2005 US$) in Brazil in 1983 to that in 1989?
Make the answer very short. 0.72. What is the ratio of the Agriculture value added per worker (constant 2005 US$) of Antigua and Barbuda in 1983 to that in 1990?
Provide a short and direct response. 0.69. What is the ratio of the Agriculture value added per worker (constant 2005 US$) of Argentina in 1983 to that in 1990?
Offer a very short reply. 1.02. What is the ratio of the Agriculture value added per worker (constant 2005 US$) in Brazil in 1983 to that in 1990?
Offer a terse response. 0.73. What is the ratio of the Agriculture value added per worker (constant 2005 US$) in Antigua and Barbuda in 1984 to that in 1985?
Give a very brief answer. 1.03. What is the ratio of the Agriculture value added per worker (constant 2005 US$) in Argentina in 1984 to that in 1985?
Offer a terse response. 1.03. What is the ratio of the Agriculture value added per worker (constant 2005 US$) in Brazil in 1984 to that in 1985?
Offer a very short reply. 0.9. What is the ratio of the Agriculture value added per worker (constant 2005 US$) of Antigua and Barbuda in 1984 to that in 1986?
Give a very brief answer. 0.84. What is the ratio of the Agriculture value added per worker (constant 2005 US$) in Argentina in 1984 to that in 1986?
Give a very brief answer. 1.03. What is the ratio of the Agriculture value added per worker (constant 2005 US$) of Brazil in 1984 to that in 1986?
Keep it short and to the point. 0.96. What is the ratio of the Agriculture value added per worker (constant 2005 US$) of Antigua and Barbuda in 1984 to that in 1987?
Your response must be concise. 0.74. What is the ratio of the Agriculture value added per worker (constant 2005 US$) of Argentina in 1984 to that in 1987?
Provide a short and direct response. 1.07. What is the ratio of the Agriculture value added per worker (constant 2005 US$) in Brazil in 1984 to that in 1987?
Your answer should be compact. 0.82. What is the ratio of the Agriculture value added per worker (constant 2005 US$) of Antigua and Barbuda in 1984 to that in 1988?
Keep it short and to the point. 0.7. What is the ratio of the Agriculture value added per worker (constant 2005 US$) in Brazil in 1984 to that in 1988?
Ensure brevity in your answer.  0.8. What is the ratio of the Agriculture value added per worker (constant 2005 US$) in Antigua and Barbuda in 1984 to that in 1989?
Your answer should be compact. 0.66. What is the ratio of the Agriculture value added per worker (constant 2005 US$) in Argentina in 1984 to that in 1989?
Keep it short and to the point. 1.09. What is the ratio of the Agriculture value added per worker (constant 2005 US$) of Brazil in 1984 to that in 1989?
Give a very brief answer. 0.76. What is the ratio of the Agriculture value added per worker (constant 2005 US$) in Antigua and Barbuda in 1984 to that in 1990?
Ensure brevity in your answer.  0.63. What is the ratio of the Agriculture value added per worker (constant 2005 US$) of Argentina in 1984 to that in 1990?
Your answer should be very brief. 1.02. What is the ratio of the Agriculture value added per worker (constant 2005 US$) in Brazil in 1984 to that in 1990?
Provide a succinct answer. 0.76. What is the ratio of the Agriculture value added per worker (constant 2005 US$) of Antigua and Barbuda in 1985 to that in 1986?
Keep it short and to the point. 0.82. What is the ratio of the Agriculture value added per worker (constant 2005 US$) in Argentina in 1985 to that in 1986?
Keep it short and to the point. 1.01. What is the ratio of the Agriculture value added per worker (constant 2005 US$) in Brazil in 1985 to that in 1986?
Your answer should be compact. 1.07. What is the ratio of the Agriculture value added per worker (constant 2005 US$) of Antigua and Barbuda in 1985 to that in 1987?
Give a very brief answer. 0.72. What is the ratio of the Agriculture value added per worker (constant 2005 US$) of Argentina in 1985 to that in 1987?
Keep it short and to the point. 1.04. What is the ratio of the Agriculture value added per worker (constant 2005 US$) of Brazil in 1985 to that in 1987?
Offer a very short reply. 0.92. What is the ratio of the Agriculture value added per worker (constant 2005 US$) in Antigua and Barbuda in 1985 to that in 1988?
Your answer should be very brief. 0.68. What is the ratio of the Agriculture value added per worker (constant 2005 US$) in Argentina in 1985 to that in 1988?
Provide a short and direct response. 0.97. What is the ratio of the Agriculture value added per worker (constant 2005 US$) of Brazil in 1985 to that in 1988?
Offer a terse response. 0.89. What is the ratio of the Agriculture value added per worker (constant 2005 US$) in Antigua and Barbuda in 1985 to that in 1989?
Ensure brevity in your answer.  0.64. What is the ratio of the Agriculture value added per worker (constant 2005 US$) in Argentina in 1985 to that in 1989?
Provide a succinct answer. 1.07. What is the ratio of the Agriculture value added per worker (constant 2005 US$) in Brazil in 1985 to that in 1989?
Ensure brevity in your answer.  0.84. What is the ratio of the Agriculture value added per worker (constant 2005 US$) of Antigua and Barbuda in 1985 to that in 1990?
Give a very brief answer. 0.61. What is the ratio of the Agriculture value added per worker (constant 2005 US$) of Brazil in 1985 to that in 1990?
Provide a succinct answer. 0.85. What is the ratio of the Agriculture value added per worker (constant 2005 US$) of Antigua and Barbuda in 1986 to that in 1987?
Your answer should be compact. 0.88. What is the ratio of the Agriculture value added per worker (constant 2005 US$) in Argentina in 1986 to that in 1987?
Your response must be concise. 1.04. What is the ratio of the Agriculture value added per worker (constant 2005 US$) of Brazil in 1986 to that in 1987?
Make the answer very short. 0.86. What is the ratio of the Agriculture value added per worker (constant 2005 US$) of Antigua and Barbuda in 1986 to that in 1988?
Keep it short and to the point. 0.83. What is the ratio of the Agriculture value added per worker (constant 2005 US$) of Argentina in 1986 to that in 1988?
Offer a terse response. 0.97. What is the ratio of the Agriculture value added per worker (constant 2005 US$) of Brazil in 1986 to that in 1988?
Make the answer very short. 0.83. What is the ratio of the Agriculture value added per worker (constant 2005 US$) in Antigua and Barbuda in 1986 to that in 1989?
Your answer should be compact. 0.79. What is the ratio of the Agriculture value added per worker (constant 2005 US$) in Argentina in 1986 to that in 1989?
Provide a succinct answer. 1.06. What is the ratio of the Agriculture value added per worker (constant 2005 US$) in Brazil in 1986 to that in 1989?
Your response must be concise. 0.79. What is the ratio of the Agriculture value added per worker (constant 2005 US$) in Antigua and Barbuda in 1986 to that in 1990?
Give a very brief answer. 0.74. What is the ratio of the Agriculture value added per worker (constant 2005 US$) of Argentina in 1986 to that in 1990?
Give a very brief answer. 0.99. What is the ratio of the Agriculture value added per worker (constant 2005 US$) in Brazil in 1986 to that in 1990?
Make the answer very short. 0.8. What is the ratio of the Agriculture value added per worker (constant 2005 US$) in Antigua and Barbuda in 1987 to that in 1988?
Provide a short and direct response. 0.94. What is the ratio of the Agriculture value added per worker (constant 2005 US$) of Argentina in 1987 to that in 1988?
Your answer should be very brief. 0.93. What is the ratio of the Agriculture value added per worker (constant 2005 US$) in Antigua and Barbuda in 1987 to that in 1989?
Make the answer very short. 0.9. What is the ratio of the Agriculture value added per worker (constant 2005 US$) in Argentina in 1987 to that in 1989?
Offer a very short reply. 1.02. What is the ratio of the Agriculture value added per worker (constant 2005 US$) in Brazil in 1987 to that in 1989?
Your response must be concise. 0.92. What is the ratio of the Agriculture value added per worker (constant 2005 US$) of Antigua and Barbuda in 1987 to that in 1990?
Keep it short and to the point. 0.85. What is the ratio of the Agriculture value added per worker (constant 2005 US$) in Brazil in 1987 to that in 1990?
Provide a short and direct response. 0.93. What is the ratio of the Agriculture value added per worker (constant 2005 US$) in Antigua and Barbuda in 1988 to that in 1989?
Keep it short and to the point. 0.95. What is the ratio of the Agriculture value added per worker (constant 2005 US$) of Argentina in 1988 to that in 1989?
Your response must be concise. 1.1. What is the ratio of the Agriculture value added per worker (constant 2005 US$) of Antigua and Barbuda in 1988 to that in 1990?
Your answer should be very brief. 0.9. What is the ratio of the Agriculture value added per worker (constant 2005 US$) of Argentina in 1988 to that in 1990?
Offer a terse response. 1.02. What is the ratio of the Agriculture value added per worker (constant 2005 US$) of Brazil in 1988 to that in 1990?
Give a very brief answer. 0.96. What is the ratio of the Agriculture value added per worker (constant 2005 US$) in Antigua and Barbuda in 1989 to that in 1990?
Make the answer very short. 0.94. What is the ratio of the Agriculture value added per worker (constant 2005 US$) of Argentina in 1989 to that in 1990?
Offer a terse response. 0.93. What is the ratio of the Agriculture value added per worker (constant 2005 US$) in Brazil in 1989 to that in 1990?
Ensure brevity in your answer.  1.01. What is the difference between the highest and the second highest Agriculture value added per worker (constant 2005 US$) in Antigua and Barbuda?
Offer a terse response. 117.46. What is the difference between the highest and the second highest Agriculture value added per worker (constant 2005 US$) in Argentina?
Make the answer very short. 30.62. What is the difference between the highest and the second highest Agriculture value added per worker (constant 2005 US$) in Brazil?
Offer a very short reply. 16.13. What is the difference between the highest and the lowest Agriculture value added per worker (constant 2005 US$) of Antigua and Barbuda?
Give a very brief answer. 815.05. What is the difference between the highest and the lowest Agriculture value added per worker (constant 2005 US$) of Argentina?
Ensure brevity in your answer.  663.19. What is the difference between the highest and the lowest Agriculture value added per worker (constant 2005 US$) of Brazil?
Your response must be concise. 481.74. 